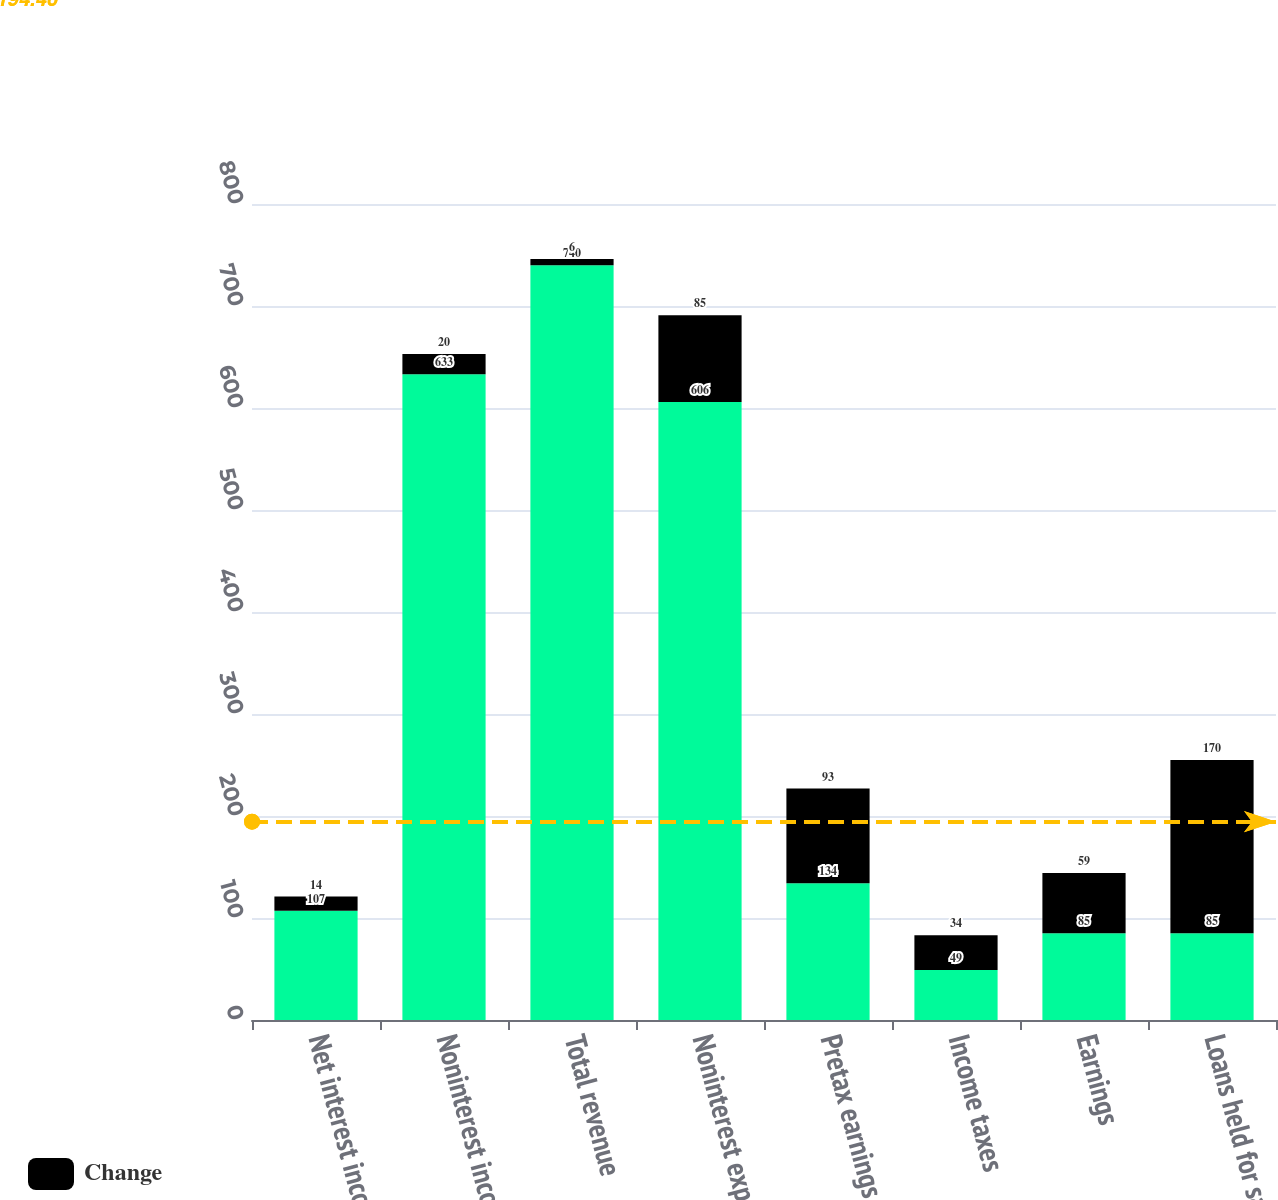Convert chart to OTSL. <chart><loc_0><loc_0><loc_500><loc_500><stacked_bar_chart><ecel><fcel>Net interest income<fcel>Noninterest income<fcel>Total revenue<fcel>Noninterest expense<fcel>Pretax earnings<fcel>Income taxes<fcel>Earnings<fcel>Loans held for sale<nl><fcel>nan<fcel>107<fcel>633<fcel>740<fcel>606<fcel>134<fcel>49<fcel>85<fcel>85<nl><fcel>Change<fcel>14<fcel>20<fcel>6<fcel>85<fcel>93<fcel>34<fcel>59<fcel>170<nl></chart> 